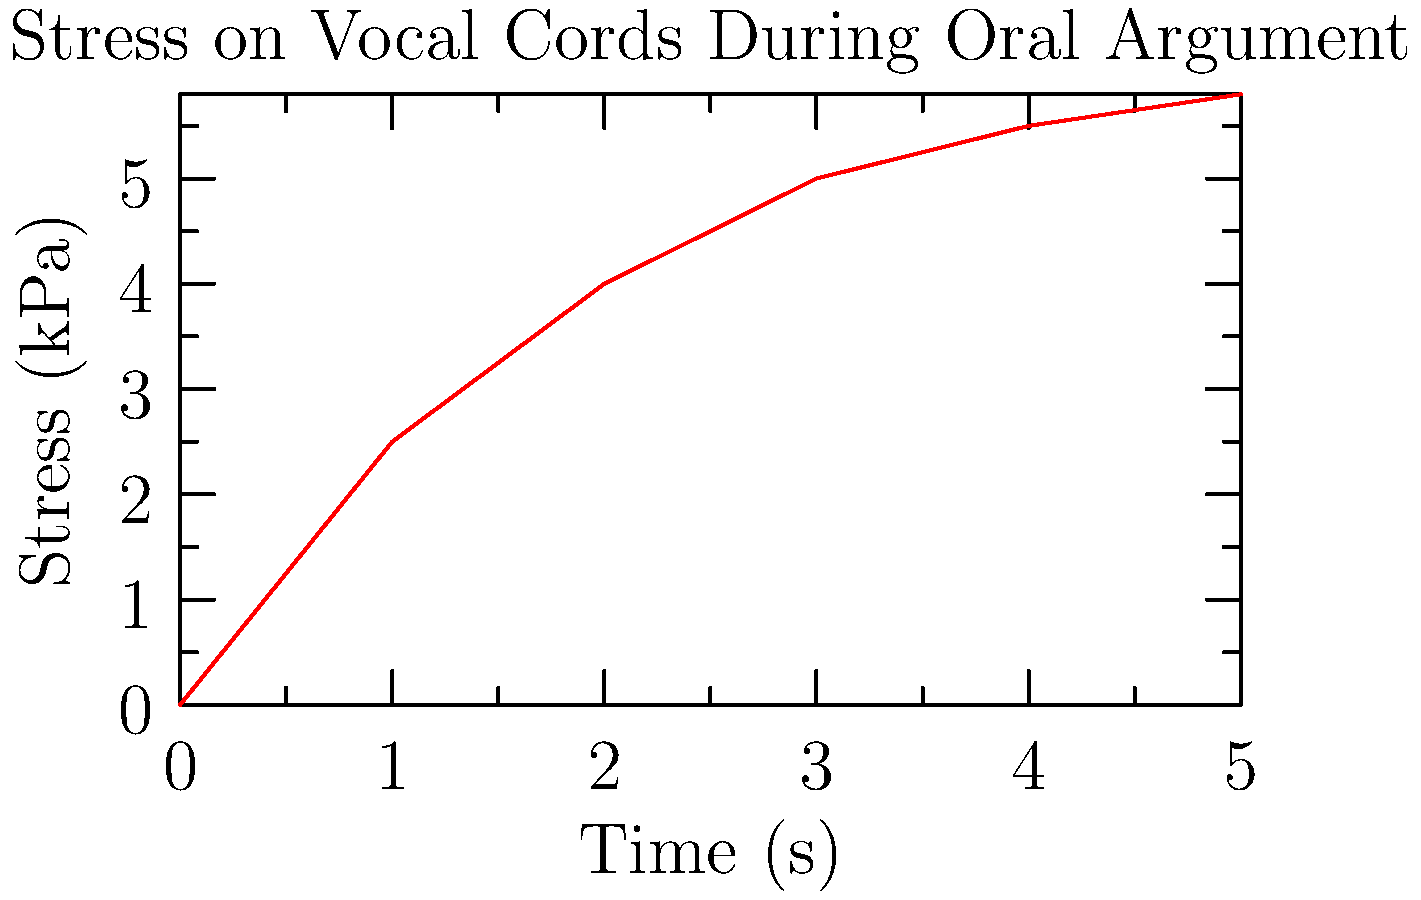During a passionate oral argument, the stress on a Supreme Court Justice's vocal cords increases over time, as shown in the graph. If the Justice continues arguing at this intensity, at what time (in seconds) will the stress on their vocal cords reach 6 kPa, assuming the trend continues? To solve this problem, we need to analyze the graph and extrapolate the trend:

1. Observe that the stress increases rapidly at first, then begins to level off.
2. The curve appears to follow a logarithmic or exponential growth pattern.
3. At t = 5 seconds, the stress is approximately 5.8 kPa.
4. The rate of increase is slowing, but still positive.
5. Extrapolating the curve, we can estimate that it will reach 6 kPa shortly after t = 5 seconds.
6. Given the decreasing rate of change, a reasonable estimate would be between 6 and 7 seconds.
7. Considering the importance of vocal health for a Justice known for passionate arguments, we should err on the side of caution and choose the lower estimate.

Therefore, assuming the trend continues, the stress on the vocal cords will likely reach 6 kPa at approximately 6 seconds.
Answer: 6 seconds 